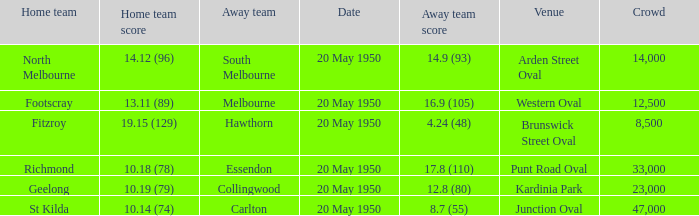Which team was the away team when the game was at punt road oval? Essendon. 